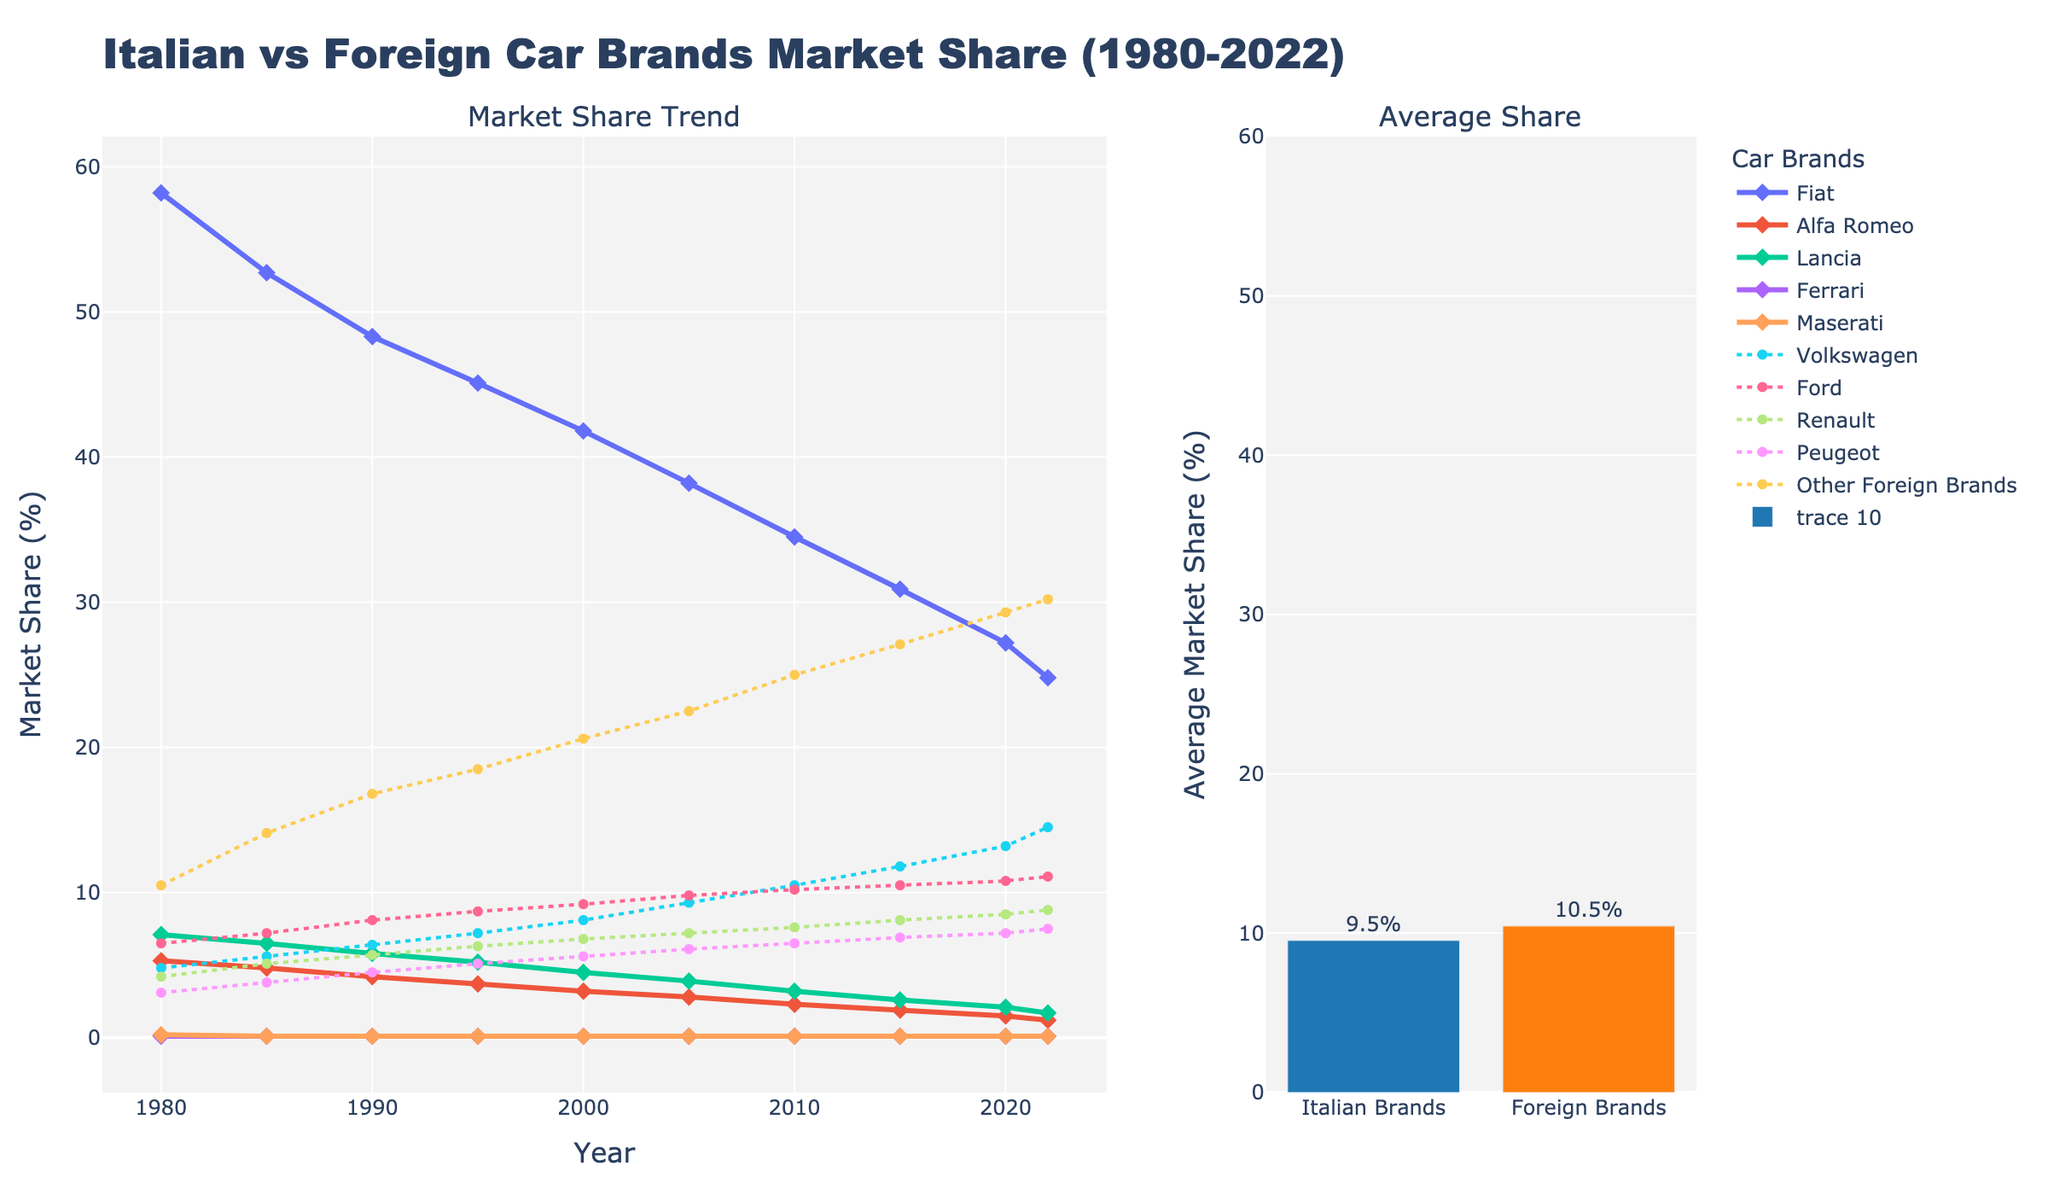What's the highest market share achieved by Fiat according to the plot? Look at the line representing Fiat in the plot. Identify the peak point and read the corresponding y-axis value. In 1980, Fiat's market share was the highest at 58.2%.
Answer: 58.2% How did the market share of Volkswagen change from 1980 to 2022? Find the line for Volkswagen. Compare the y-axis value at the start of the period (1980) with the value at the end (2022). In 1980, it was 4.8%, and in 2022, it reached 14.5%. The market share increased.
Answer: Increased Which brand had a higher market share in 2022, Ford or Renault? Locate the lines representing Ford and Renault at the year 2022. Compare their y-axis values. Ford had 11.1%, and Renault had 8.8%. Thus, Ford had a higher market share.
Answer: Ford What is the average market share of Italian brands compared to foreign brands? Refer to the bar chart in the subplot that shows average market shares. Read the y-axis values for the bars representing Italian and Foreign brands. The average market share for Italian brands is approximately 7.7%, and for foreign brands it’s approximately 12.2%.
Answer: Italian: 7.7%, Foreign: 12.2% Between which years did Fiat experience the sharpest decline in market share? Track Fiat's line for the steepest downward slope. The steepest decline appears between 1980 to 1985. The market share decreased from 58.2% to 52.7%.
Answer: 1980-1985 What were the combined market shares of Ferrari and Maserati in 2000? Find the market shares for Ferrari and Maserati in 2000. Add their y-axis values: Ferrari (0.1%) + Maserati (0.1%). The combined market share is 0.2%.
Answer: 0.2% Which brand showed a consistent increase in market share across the entire period? Analyze the lines for each brand. Volkswagen shows a consistent increase, starting from 4.8% in 1980 to 14.5% in 2022.
Answer: Volkswagen Which Italian brand has the smallest average market share? Assess the subplot bar chart representing averages and identify the smallest bar among the Italian brands (left bar). Lancia has the smallest market share.
Answer: Lancia 